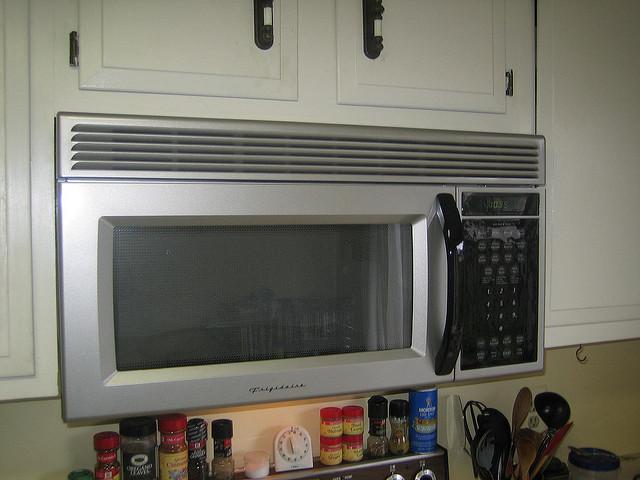What company built this oven?
Concise answer only. Frigidaire. Why should seasonings not be kept in this location?
Answer briefly. Heat. What's directly below the device in the center?
Answer briefly. Spices. What kind of device is this?
Quick response, please. Microwave. 